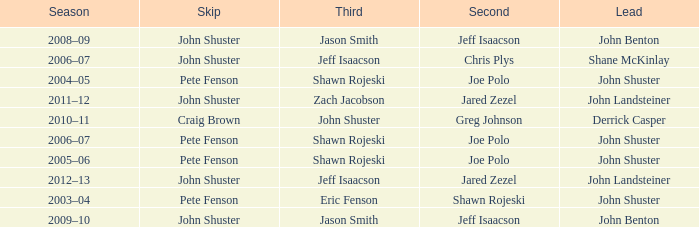Which season has Zach Jacobson in third? 2011–12. 